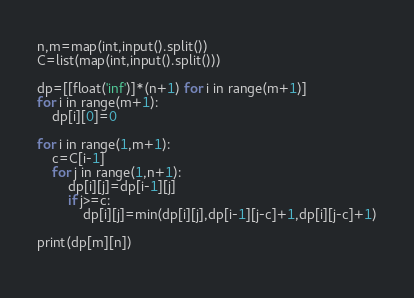Convert code to text. <code><loc_0><loc_0><loc_500><loc_500><_Python_>n,m=map(int,input().split())
C=list(map(int,input().split()))

dp=[[float('inf')]*(n+1) for i in range(m+1)]
for i in range(m+1):
    dp[i][0]=0

for i in range(1,m+1):
    c=C[i-1]
    for j in range(1,n+1):
        dp[i][j]=dp[i-1][j]
        if j>=c:
            dp[i][j]=min(dp[i][j],dp[i-1][j-c]+1,dp[i][j-c]+1)

print(dp[m][n])
        
</code> 